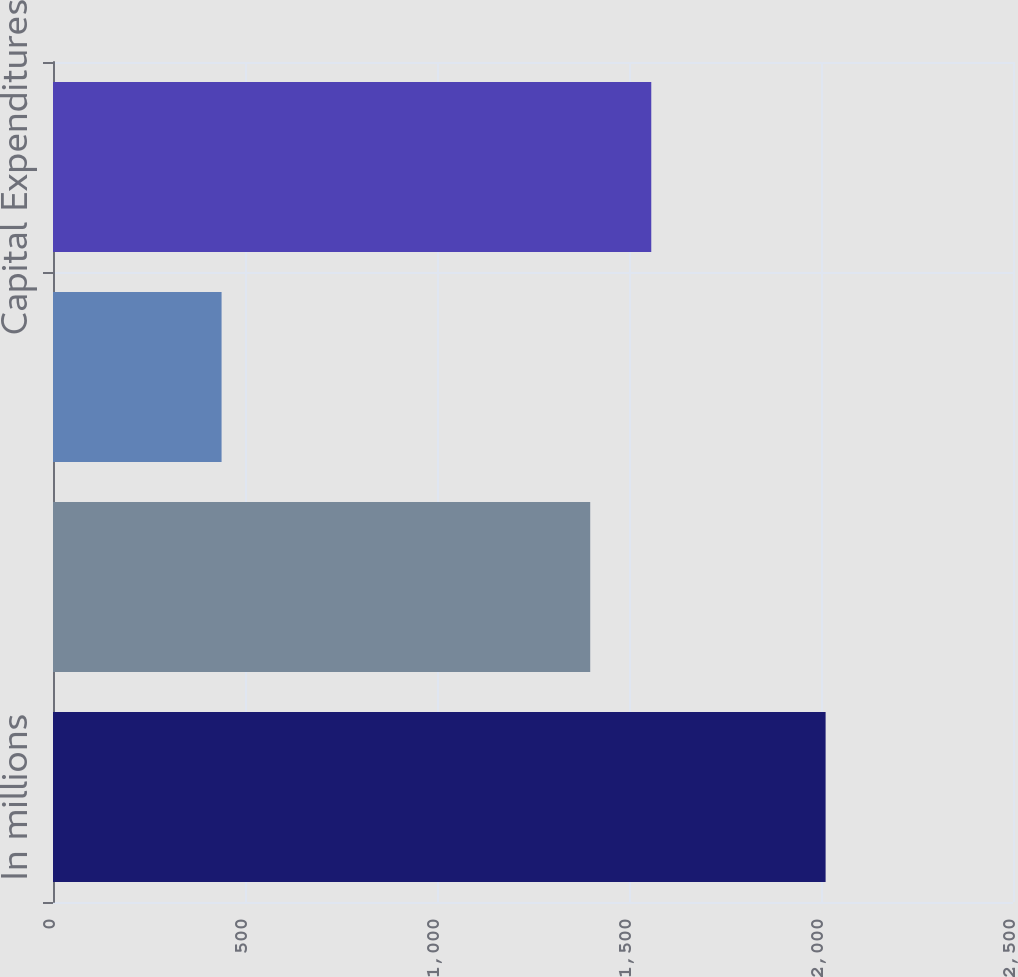Convert chart to OTSL. <chart><loc_0><loc_0><loc_500><loc_500><bar_chart><fcel>In millions<fcel>Segment Sales<fcel>Segment Earnings<fcel>Capital Expenditures<nl><fcel>2012<fcel>1399<fcel>439<fcel>1558<nl></chart> 